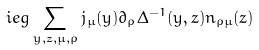<formula> <loc_0><loc_0><loc_500><loc_500>i e g \sum _ { y , z , \mu , \rho } j _ { \mu } ( y ) \partial _ { \rho } \Delta ^ { - 1 } ( y , z ) n _ { \rho \mu } ( z )</formula> 